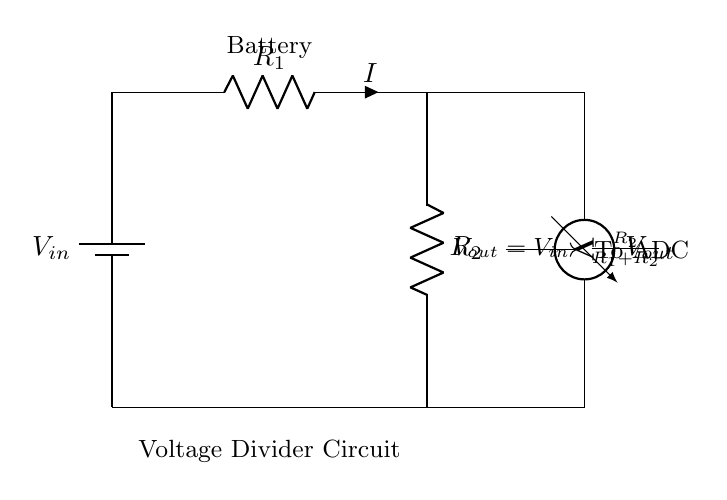What is the input voltage in this circuit? The input voltage is labeled as V in the circuit diagram, which indicates the voltage supplied by the battery.
Answer: V in What are the two resistors in this voltage divider? The two resistors in the voltage divider circuit are labeled as R1 and R2, indicating their respective roles in dividing the voltage.
Answer: R1, R2 What does the voltmeter measure in this circuit? The voltmeter is connected across R2 and is used to measure the output voltage, which is denoted as V out in the circuit diagram.
Answer: V out What is the formula for calculating output voltage in a voltage divider? The formula provided in the circuit diagram states that V out is equal to V in multiplied by the fraction of R2 over the sum of R1 and R2, which shows how the output voltage is derived from the input voltage and resistor values.
Answer: V out = V in * (R2 / (R1 + R2)) If the resistance values are known, how would you calculate the output voltage? In order to calculate the output voltage, you first need to plug in the specific values for V in, R1, and R2 into the formula provided in the diagram. This allows you to compute V out based on the input and resistance values.
Answer: Substitute and solve the formula What indicates that this circuit is a voltage divider? The configuration of two resistors in series connected to a voltage source with output taken across one of the resistors characterizes this circuit as a voltage divider, as this arrangement is specifically designed to divide voltage.
Answer: Two resistors in series Where does the output voltage go to after measurement? The output voltage from the voltmeter is indicated to proceed towards an analog-to-digital converter (ADC) in the circuit, which suggests that the measured voltage will be converted into a digital signal for further processing.
Answer: To ADC 